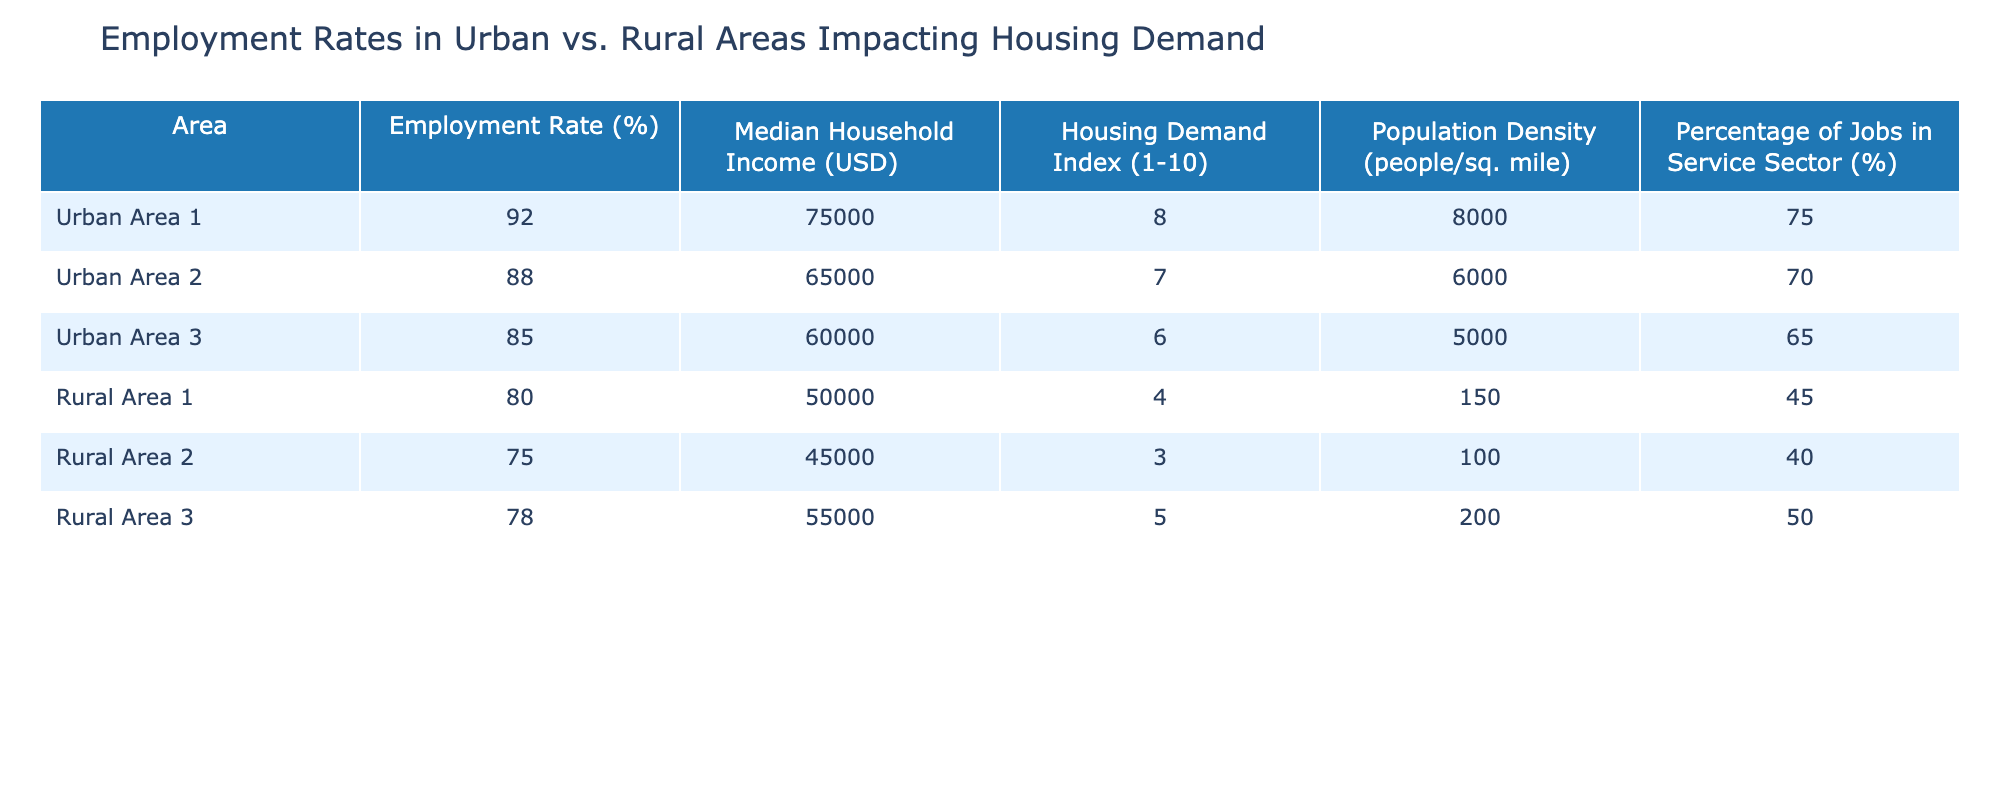What is the employment rate in Urban Area 1? The table shows that the employment rate for Urban Area 1 is listed directly in the corresponding row. It is 92%.
Answer: 92% Which area has the highest median household income? To find the area with the highest median household income, we can compare the values in the "Median Household Income" column. Urban Area 1 has the highest income at $75,000.
Answer: Urban Area 1 What is the housing demand index for Rural Area 2? By looking at the "Housing Demand Index" column for Rural Area 2 in the table, the value is listed as 3.
Answer: 3 How much higher is the employment rate in Urban Area 1 compared to Rural Area 3? The employment rate for Urban Area 1 is 92% and for Rural Area 3 it is 78%. By calculating the difference, we find that 92% - 78% = 14%.
Answer: 14% Is the median household income in Rural Area 1 greater than $50,000? We can check the "Median Household Income" for Rural Area 1 in the table, which is $50,000. Since the question asks if it is greater, the answer is no.
Answer: No What is the average housing demand index for the rural areas? The housing demand indices for the rural areas are 4, 3, and 5. We can sum these values: 4 + 3 + 5 = 12, and since there are three areas, we divide the total by 3, resulting in an average of 12 / 3 = 4.
Answer: 4 Which area has the lowest percentage of jobs in the service sector? By reviewing the "Percentage of Jobs in Service Sector" column, Rural Area 2 has the lowest percentage at 40%.
Answer: Rural Area 2 What is the difference in population density between Urban Area 2 and Rural Area 1? The population density for Urban Area 2 is 6,000 and for Rural Area 1 is 150. The difference is calculated by subtracting 150 from 6,000, which equals 5,850.
Answer: 5,850 Does Urban Area 3 have a housing demand index of six or greater? Looking at the "Housing Demand Index" for Urban Area 3, it is 6. Since it equals six, the answer is yes.
Answer: Yes 